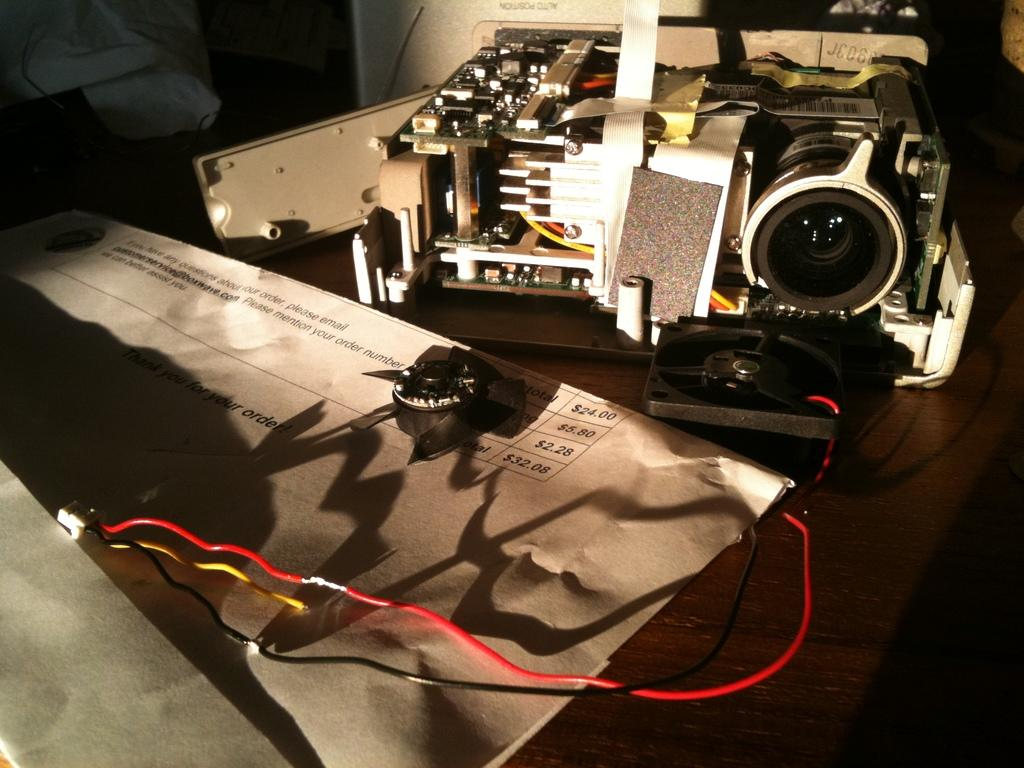What is the main object in the image? There is a projector lens machine in the image. Where is the projector lens machine placed? The projector lens machine is placed on a wooden table. What type of object can be seen in a brown color in the image? There is a brown color envelope in the image. What color is the cable in the image? There is a red color cable in the image. What small electronic component is present in the image? There is a small black color computer fan in the image. What type of loaf is being used to power the projector lens machine in the image? There is no loaf present in the image, and the projector lens machine is not powered by a loaf. Can you see a tank in the image? No, there is no tank present in the image. 